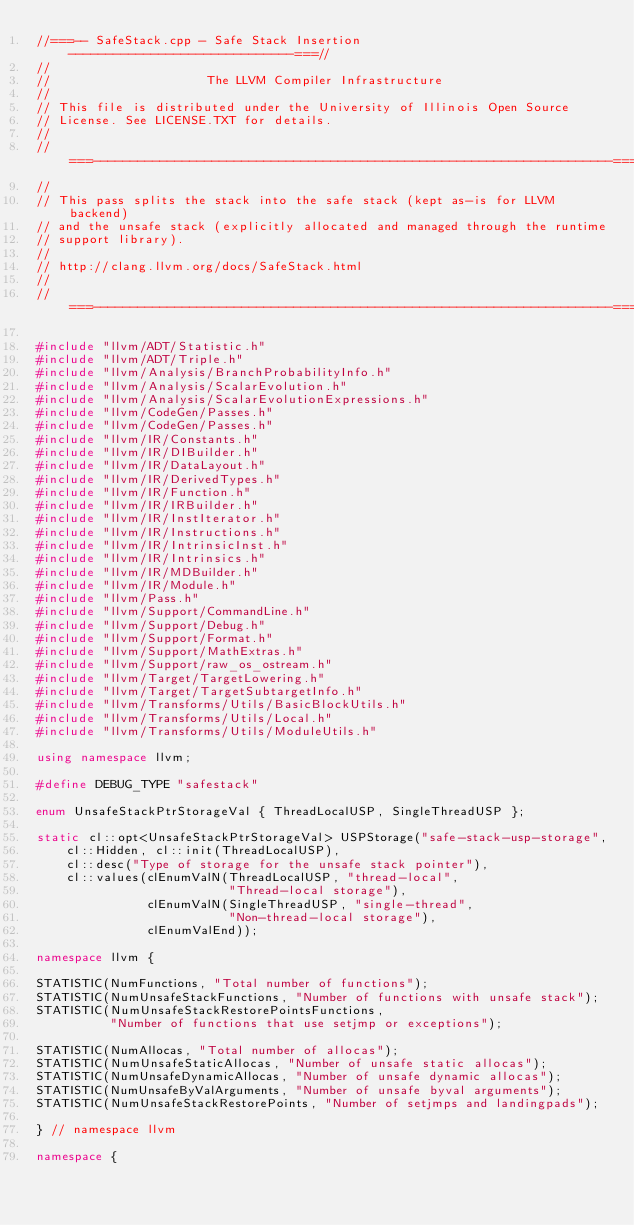<code> <loc_0><loc_0><loc_500><loc_500><_C++_>//===-- SafeStack.cpp - Safe Stack Insertion ------------------------------===//
//
//                     The LLVM Compiler Infrastructure
//
// This file is distributed under the University of Illinois Open Source
// License. See LICENSE.TXT for details.
//
//===----------------------------------------------------------------------===//
//
// This pass splits the stack into the safe stack (kept as-is for LLVM backend)
// and the unsafe stack (explicitly allocated and managed through the runtime
// support library).
//
// http://clang.llvm.org/docs/SafeStack.html
//
//===----------------------------------------------------------------------===//

#include "llvm/ADT/Statistic.h"
#include "llvm/ADT/Triple.h"
#include "llvm/Analysis/BranchProbabilityInfo.h"
#include "llvm/Analysis/ScalarEvolution.h"
#include "llvm/Analysis/ScalarEvolutionExpressions.h"
#include "llvm/CodeGen/Passes.h"
#include "llvm/CodeGen/Passes.h"
#include "llvm/IR/Constants.h"
#include "llvm/IR/DIBuilder.h"
#include "llvm/IR/DataLayout.h"
#include "llvm/IR/DerivedTypes.h"
#include "llvm/IR/Function.h"
#include "llvm/IR/IRBuilder.h"
#include "llvm/IR/InstIterator.h"
#include "llvm/IR/Instructions.h"
#include "llvm/IR/IntrinsicInst.h"
#include "llvm/IR/Intrinsics.h"
#include "llvm/IR/MDBuilder.h"
#include "llvm/IR/Module.h"
#include "llvm/Pass.h"
#include "llvm/Support/CommandLine.h"
#include "llvm/Support/Debug.h"
#include "llvm/Support/Format.h"
#include "llvm/Support/MathExtras.h"
#include "llvm/Support/raw_os_ostream.h"
#include "llvm/Target/TargetLowering.h"
#include "llvm/Target/TargetSubtargetInfo.h"
#include "llvm/Transforms/Utils/BasicBlockUtils.h"
#include "llvm/Transforms/Utils/Local.h"
#include "llvm/Transforms/Utils/ModuleUtils.h"

using namespace llvm;

#define DEBUG_TYPE "safestack"

enum UnsafeStackPtrStorageVal { ThreadLocalUSP, SingleThreadUSP };

static cl::opt<UnsafeStackPtrStorageVal> USPStorage("safe-stack-usp-storage",
    cl::Hidden, cl::init(ThreadLocalUSP),
    cl::desc("Type of storage for the unsafe stack pointer"),
    cl::values(clEnumValN(ThreadLocalUSP, "thread-local",
                          "Thread-local storage"),
               clEnumValN(SingleThreadUSP, "single-thread",
                          "Non-thread-local storage"),
               clEnumValEnd));

namespace llvm {

STATISTIC(NumFunctions, "Total number of functions");
STATISTIC(NumUnsafeStackFunctions, "Number of functions with unsafe stack");
STATISTIC(NumUnsafeStackRestorePointsFunctions,
          "Number of functions that use setjmp or exceptions");

STATISTIC(NumAllocas, "Total number of allocas");
STATISTIC(NumUnsafeStaticAllocas, "Number of unsafe static allocas");
STATISTIC(NumUnsafeDynamicAllocas, "Number of unsafe dynamic allocas");
STATISTIC(NumUnsafeByValArguments, "Number of unsafe byval arguments");
STATISTIC(NumUnsafeStackRestorePoints, "Number of setjmps and landingpads");

} // namespace llvm

namespace {
</code> 